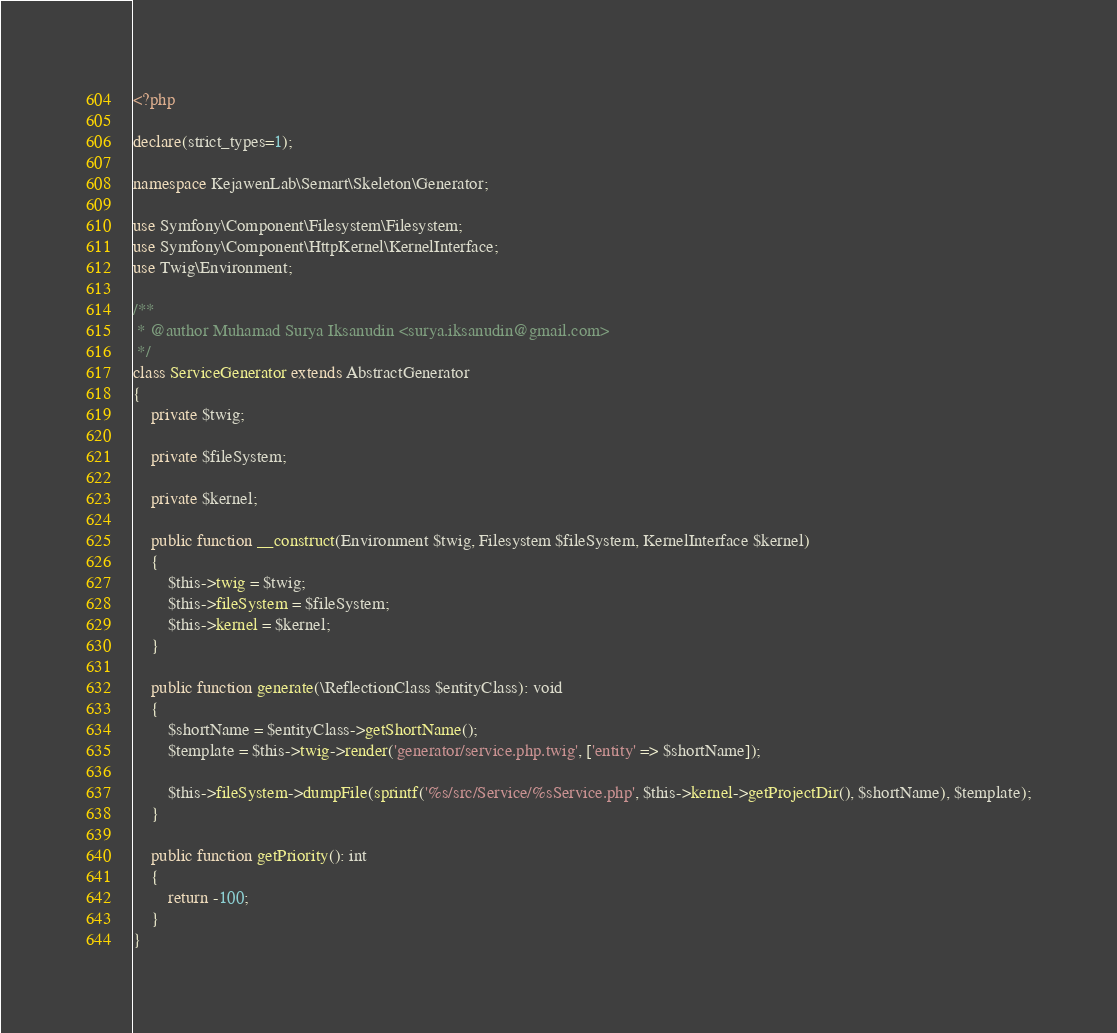<code> <loc_0><loc_0><loc_500><loc_500><_PHP_><?php

declare(strict_types=1);

namespace KejawenLab\Semart\Skeleton\Generator;

use Symfony\Component\Filesystem\Filesystem;
use Symfony\Component\HttpKernel\KernelInterface;
use Twig\Environment;

/**
 * @author Muhamad Surya Iksanudin <surya.iksanudin@gmail.com>
 */
class ServiceGenerator extends AbstractGenerator
{
    private $twig;

    private $fileSystem;

    private $kernel;

    public function __construct(Environment $twig, Filesystem $fileSystem, KernelInterface $kernel)
    {
        $this->twig = $twig;
        $this->fileSystem = $fileSystem;
        $this->kernel = $kernel;
    }

    public function generate(\ReflectionClass $entityClass): void
    {
        $shortName = $entityClass->getShortName();
        $template = $this->twig->render('generator/service.php.twig', ['entity' => $shortName]);

        $this->fileSystem->dumpFile(sprintf('%s/src/Service/%sService.php', $this->kernel->getProjectDir(), $shortName), $template);
    }

    public function getPriority(): int
    {
        return -100;
    }
}
</code> 